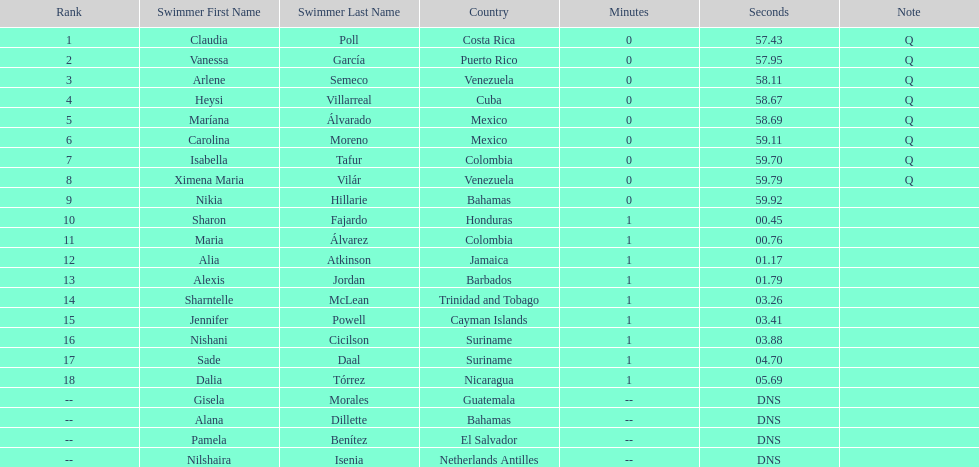Parse the full table. {'header': ['Rank', 'Swimmer First Name', 'Swimmer Last Name', 'Country', 'Minutes', 'Seconds', 'Note'], 'rows': [['1', 'Claudia', 'Poll', 'Costa Rica', '0', '57.43', 'Q'], ['2', 'Vanessa', 'García', 'Puerto Rico', '0', '57.95', 'Q'], ['3', 'Arlene', 'Semeco', 'Venezuela', '0', '58.11', 'Q'], ['4', 'Heysi', 'Villarreal', 'Cuba', '0', '58.67', 'Q'], ['5', 'Maríana', 'Álvarado', 'Mexico', '0', '58.69', 'Q'], ['6', 'Carolina', 'Moreno', 'Mexico', '0', '59.11', 'Q'], ['7', 'Isabella', 'Tafur', 'Colombia', '0', '59.70', 'Q'], ['8', 'Ximena Maria', 'Vilár', 'Venezuela', '0', '59.79', 'Q'], ['9', 'Nikia', 'Hillarie', 'Bahamas', '0', '59.92', ''], ['10', 'Sharon', 'Fajardo', 'Honduras', '1', '00.45', ''], ['11', 'Maria', 'Álvarez', 'Colombia', '1', '00.76', ''], ['12', 'Alia', 'Atkinson', 'Jamaica', '1', '01.17', ''], ['13', 'Alexis', 'Jordan', 'Barbados', '1', '01.79', ''], ['14', 'Sharntelle', 'McLean', 'Trinidad and Tobago', '1', '03.26', ''], ['15', 'Jennifer', 'Powell', 'Cayman Islands', '1', '03.41', ''], ['16', 'Nishani', 'Cicilson', 'Suriname', '1', '03.88', ''], ['17', 'Sade', 'Daal', 'Suriname', '1', '04.70', ''], ['18', 'Dalia', 'Tórrez', 'Nicaragua', '1', '05.69', ''], ['--', 'Gisela', 'Morales', 'Guatemala', '--', 'DNS', ''], ['--', 'Alana', 'Dillette', 'Bahamas', '--', 'DNS', ''], ['--', 'Pamela', 'Benítez', 'El Salvador', '--', 'DNS', ''], ['--', 'Nilshaira', 'Isenia', 'Netherlands Antilles', '--', 'DNS', '']]} How many swimmers are from mexico? 2. 